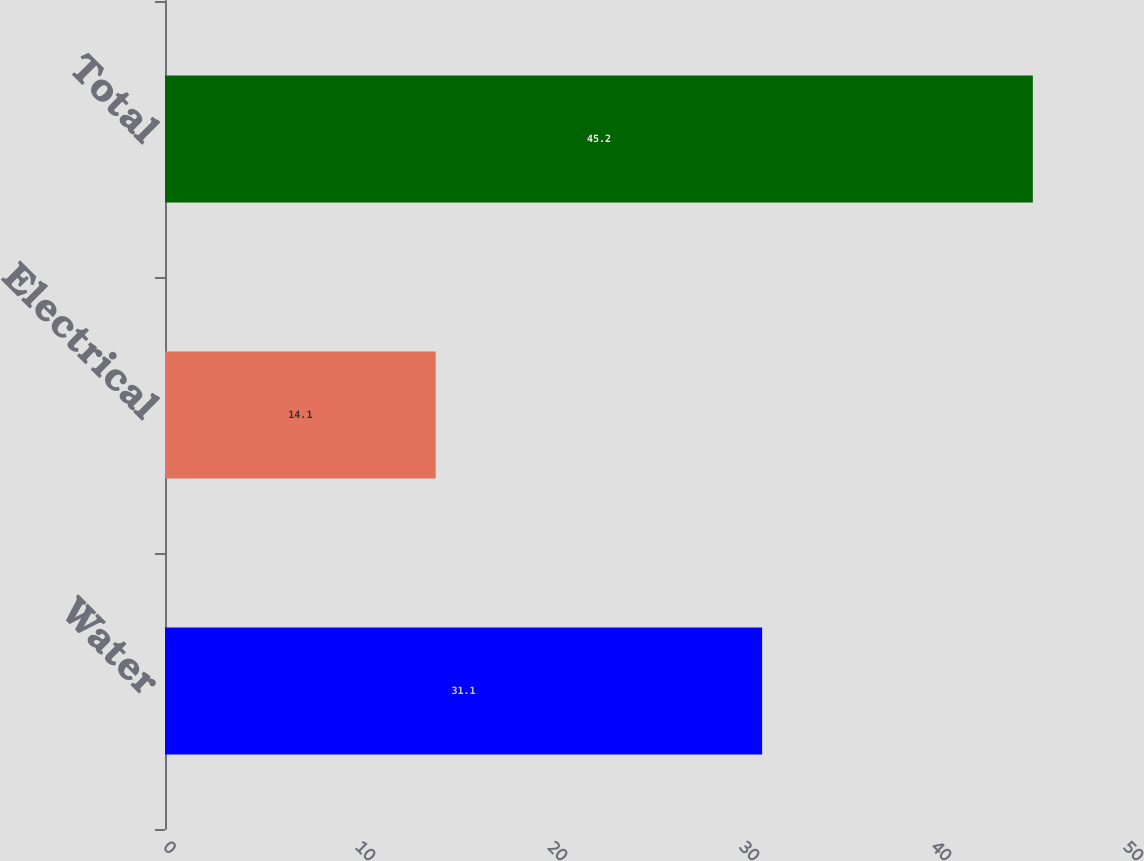Convert chart. <chart><loc_0><loc_0><loc_500><loc_500><bar_chart><fcel>Water<fcel>Electrical<fcel>Total<nl><fcel>31.1<fcel>14.1<fcel>45.2<nl></chart> 